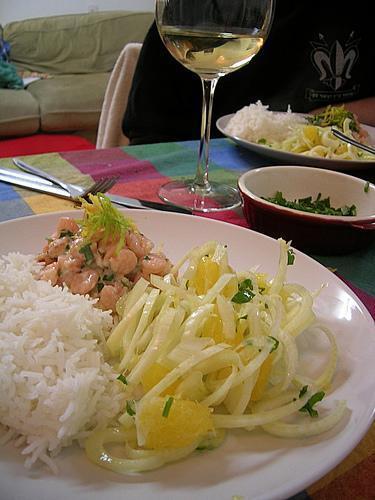How many plates are on the table?
Give a very brief answer. 2. 